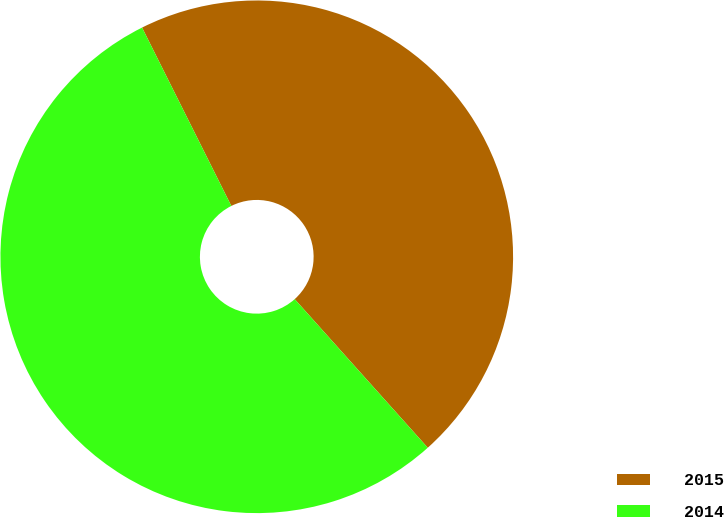Convert chart to OTSL. <chart><loc_0><loc_0><loc_500><loc_500><pie_chart><fcel>2015<fcel>2014<nl><fcel>45.76%<fcel>54.24%<nl></chart> 